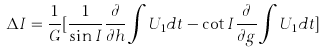<formula> <loc_0><loc_0><loc_500><loc_500>\Delta I = \frac { 1 } { G } [ \frac { 1 } { \sin I } \frac { \partial } { \partial h } \int U _ { 1 } d t - \cot I \frac { \partial } { \partial g } \int U _ { 1 } d t ]</formula> 